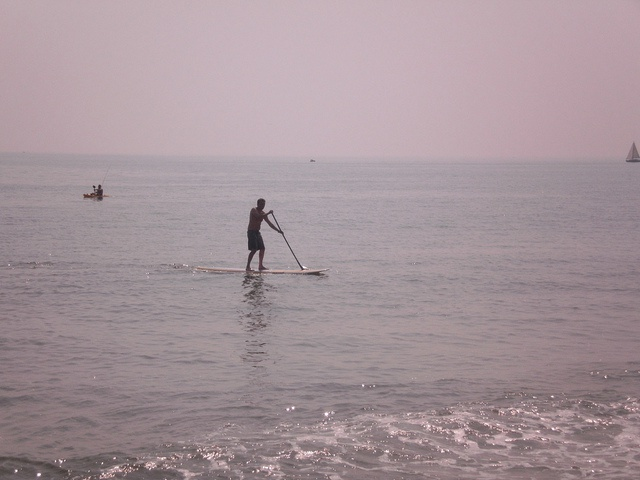Describe the objects in this image and their specific colors. I can see people in darkgray, black, and gray tones, surfboard in darkgray and gray tones, boat in darkgray and gray tones, people in darkgray, gray, and black tones, and surfboard in darkgray, maroon, brown, and gray tones in this image. 